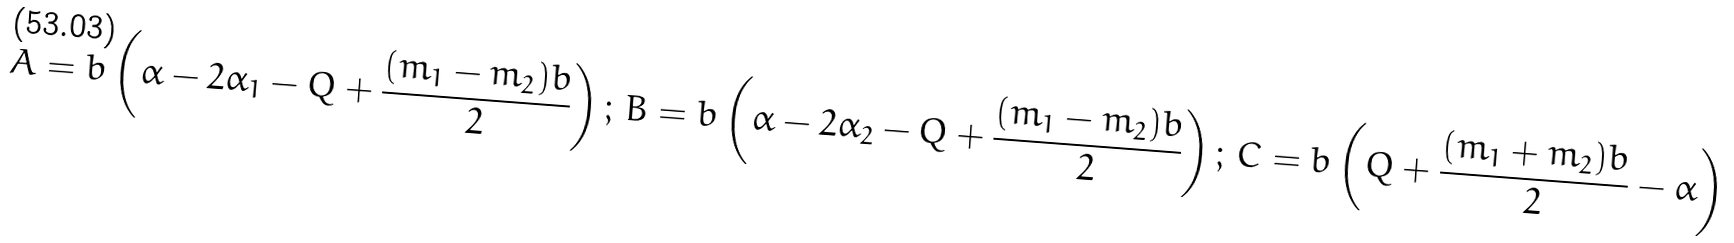Convert formula to latex. <formula><loc_0><loc_0><loc_500><loc_500>A = b \left ( \alpha - 2 \alpha _ { 1 } - Q + \frac { ( m _ { 1 } - m _ { 2 } ) b } { 2 } \right ) ; \, B = b \left ( \alpha - 2 \alpha _ { 2 } - Q + \frac { ( m _ { 1 } - m _ { 2 } ) b } { 2 } \right ) ; \, C = b \left ( Q + \frac { ( m _ { 1 } + m _ { 2 } ) b } { 2 } - \alpha \right )</formula> 